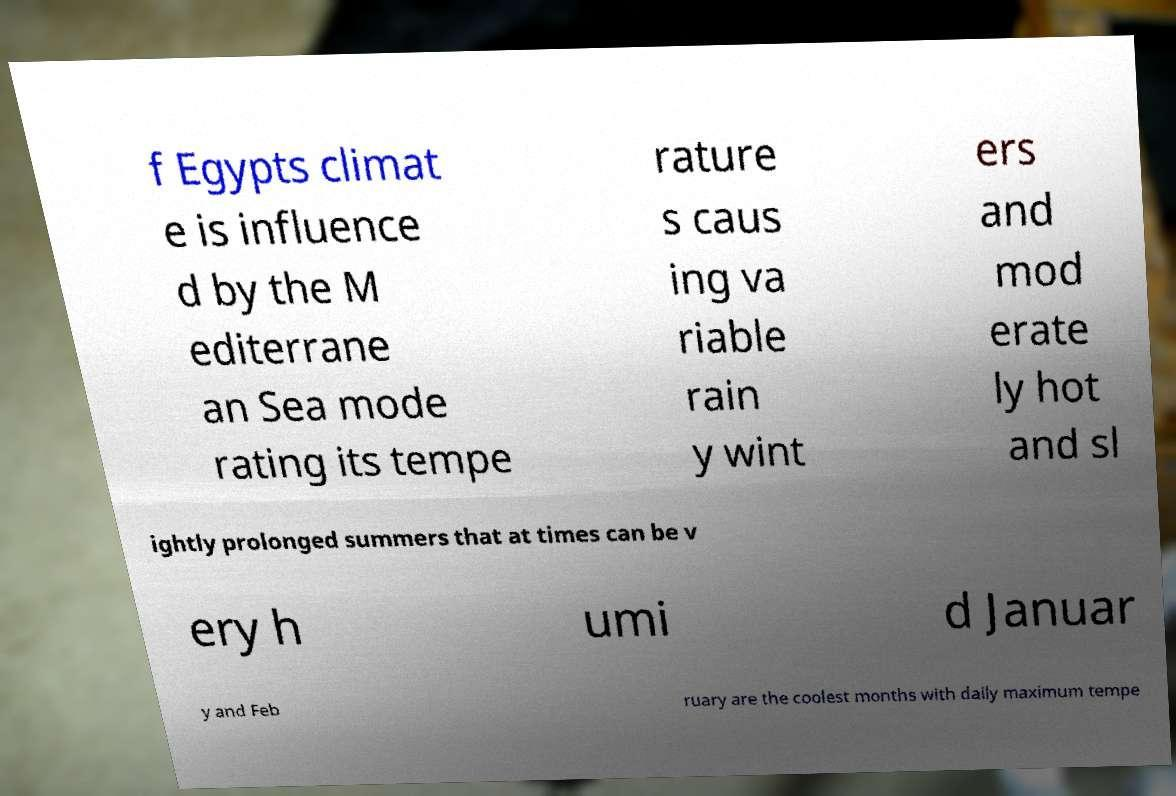For documentation purposes, I need the text within this image transcribed. Could you provide that? f Egypts climat e is influence d by the M editerrane an Sea mode rating its tempe rature s caus ing va riable rain y wint ers and mod erate ly hot and sl ightly prolonged summers that at times can be v ery h umi d Januar y and Feb ruary are the coolest months with daily maximum tempe 